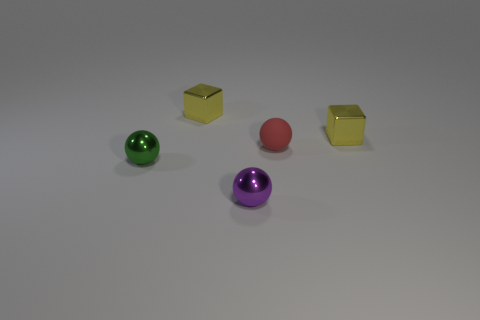How many other things are there of the same color as the tiny rubber sphere?
Provide a short and direct response. 0. Are there an equal number of small red matte objects to the right of the tiny red matte thing and red rubber balls?
Offer a terse response. No. There is a small yellow block left of the tiny metal thing to the right of the small purple metal object; how many purple metal spheres are to the left of it?
Your answer should be compact. 0. Is the size of the red rubber sphere the same as the yellow object to the left of the tiny red matte object?
Provide a short and direct response. Yes. What number of big purple balls are there?
Provide a short and direct response. 0. There is a yellow object that is on the right side of the tiny red sphere; is its size the same as the cube to the left of the tiny purple shiny sphere?
Your response must be concise. Yes. What is the color of the other tiny metal object that is the same shape as the small purple object?
Offer a very short reply. Green. Do the small red object and the purple metal thing have the same shape?
Provide a succinct answer. Yes. There is a red thing that is the same shape as the tiny purple shiny object; what is its size?
Make the answer very short. Small. What number of yellow objects have the same material as the small purple sphere?
Provide a succinct answer. 2. 